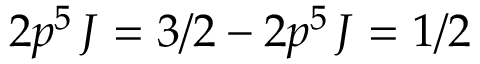Convert formula to latex. <formula><loc_0><loc_0><loc_500><loc_500>2 p ^ { 5 } \, J = 3 / 2 - 2 p ^ { 5 } \, J = 1 / 2</formula> 